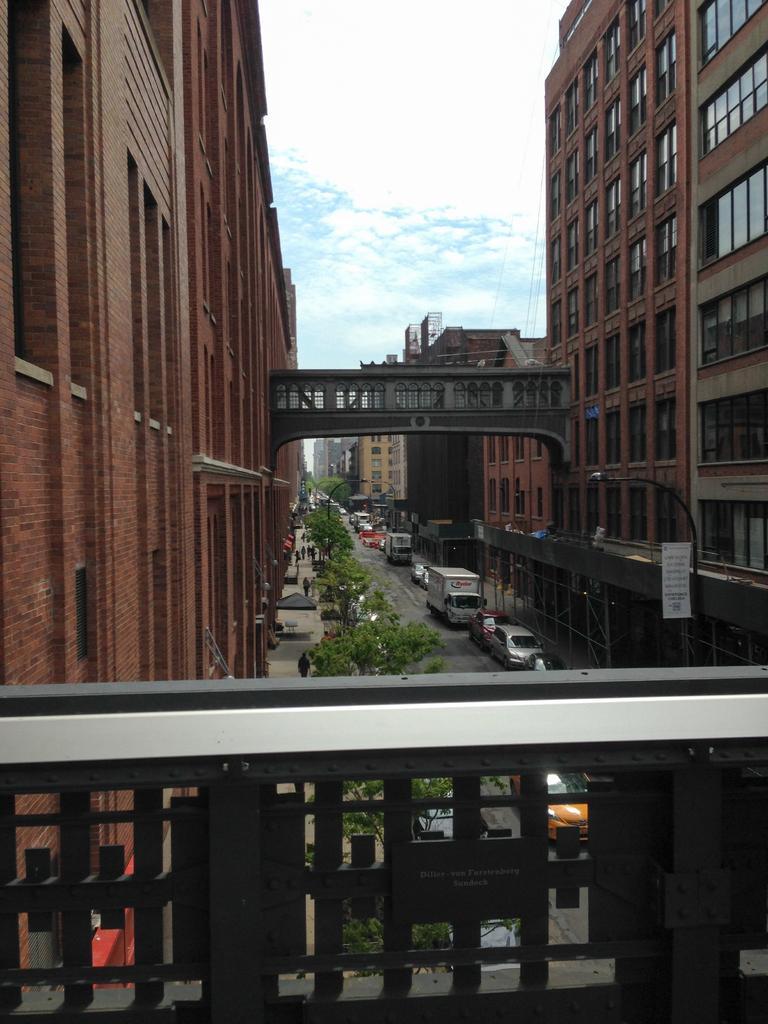In one or two sentences, can you explain what this image depicts? At the bottom of the picture, we see an iron railing. Behind that, we see the trees. Beside that, we see the vehicles are moving on the road. On either side of the picture, we see the buildings which are in brown color. On the right side, we see a board in white color with some text written. In the middle, we see a bridge. There are buildings, trees and poles in the background. At the top, we see the sky. 